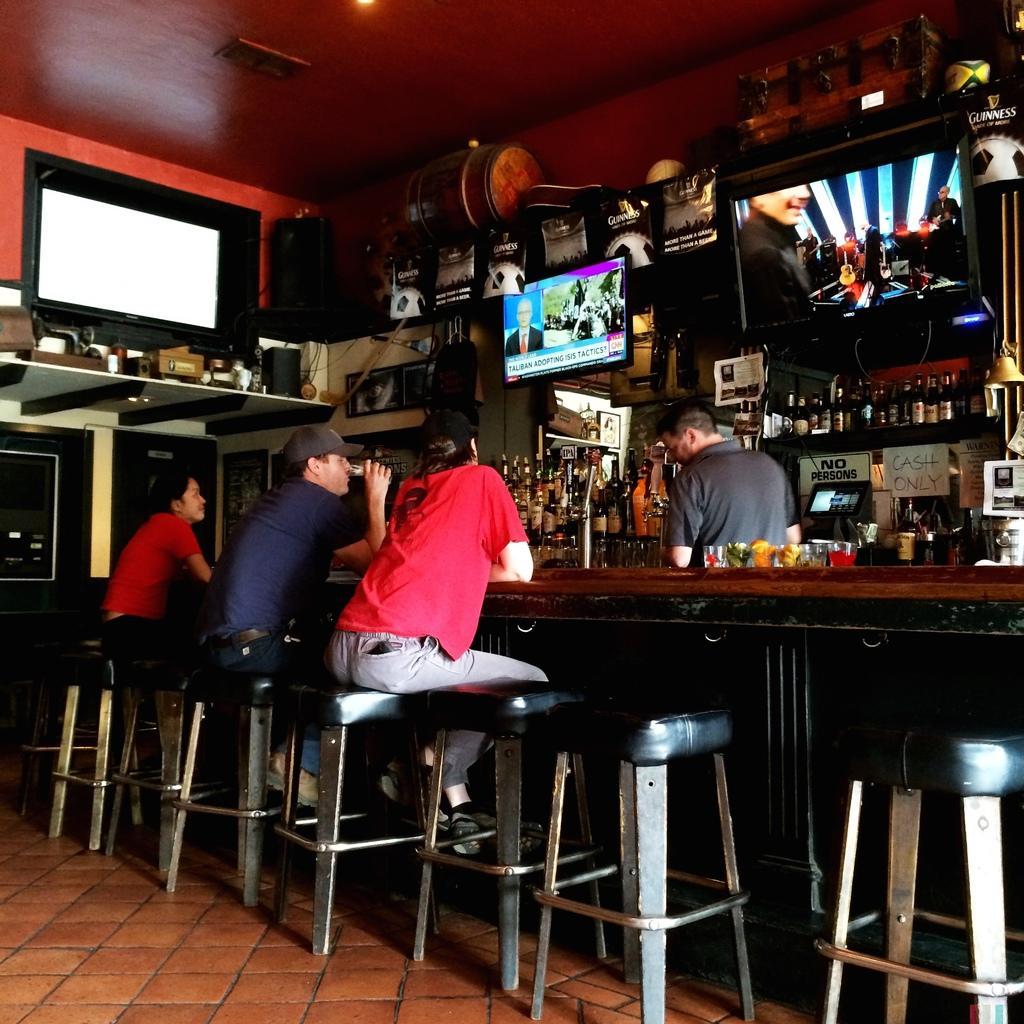How would you summarize this image in a sentence or two? In this picture, there are three men sitting on the stools in front of a table on which some drinks were placed. There is a man standing on the other side of the table. We can observe some televisions here and some drinks placed in the shelves. 